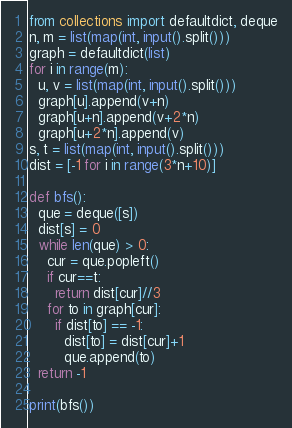Convert code to text. <code><loc_0><loc_0><loc_500><loc_500><_Python_>from collections import defaultdict, deque
n, m = list(map(int, input().split()))
graph = defaultdict(list)
for i in range(m):
  u, v = list(map(int, input().split()))
  graph[u].append(v+n)
  graph[u+n].append(v+2*n)
  graph[u+2*n].append(v)
s, t = list(map(int, input().split()))
dist = [-1 for i in range(3*n+10)]

def bfs():
  que = deque([s])
  dist[s] = 0
  while len(que) > 0:
    cur = que.popleft()
    if cur==t:
      return dist[cur]//3
    for to in graph[cur]:
      if dist[to] == -1:
        dist[to] = dist[cur]+1
        que.append(to)
  return -1

print(bfs())</code> 